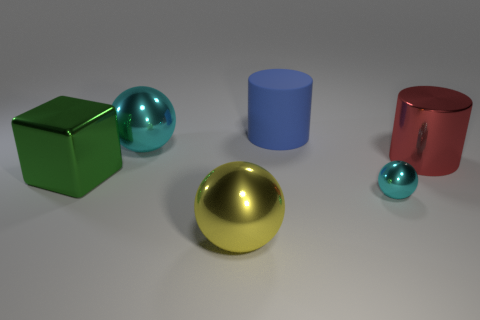There is a shiny thing that is the same color as the small shiny ball; what is its shape?
Ensure brevity in your answer.  Sphere. Is there any other thing that is the same material as the blue cylinder?
Provide a short and direct response. No. There is a small shiny object; is its color the same as the big shiny ball that is behind the yellow object?
Provide a succinct answer. Yes. How many other things are the same shape as the big green metallic thing?
Keep it short and to the point. 0. What number of objects are cyan balls that are to the left of the tiny ball or things to the left of the blue matte thing?
Ensure brevity in your answer.  3. How big is the metal object that is behind the green object and left of the large red object?
Ensure brevity in your answer.  Large. There is a large metal object in front of the big green shiny block; does it have the same shape as the matte object?
Offer a very short reply. No. There is a cyan metallic thing in front of the big thing that is left of the sphere behind the big red metallic object; what is its size?
Keep it short and to the point. Small. How many things are large metallic cylinders or small brown rubber blocks?
Provide a short and direct response. 1. There is a object that is on the right side of the blue rubber cylinder and in front of the big shiny block; what shape is it?
Ensure brevity in your answer.  Sphere. 